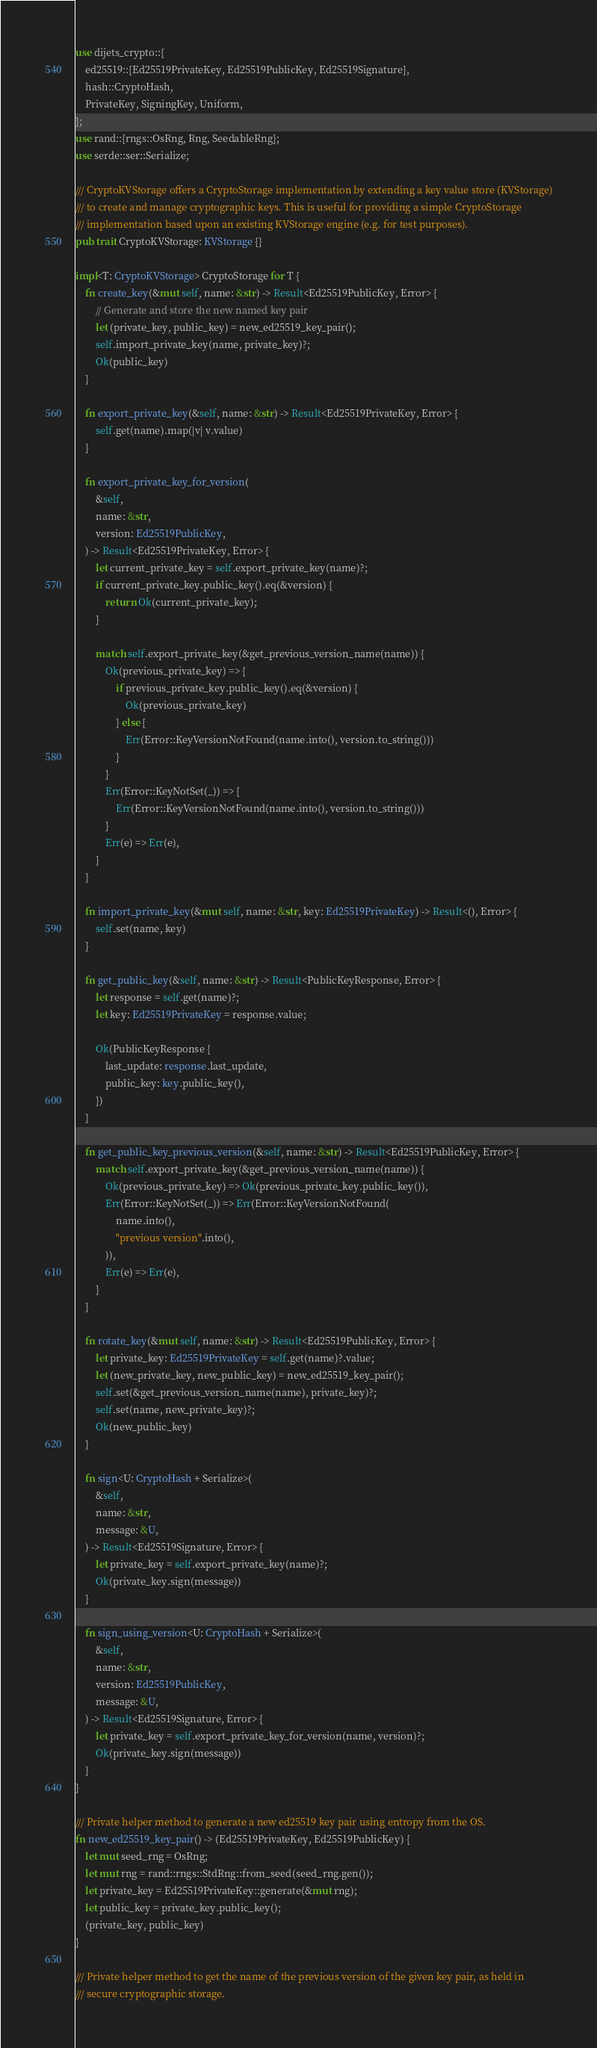Convert code to text. <code><loc_0><loc_0><loc_500><loc_500><_Rust_>use dijets_crypto::{
    ed25519::{Ed25519PrivateKey, Ed25519PublicKey, Ed25519Signature},
    hash::CryptoHash,
    PrivateKey, SigningKey, Uniform,
};
use rand::{rngs::OsRng, Rng, SeedableRng};
use serde::ser::Serialize;

/// CryptoKVStorage offers a CryptoStorage implementation by extending a key value store (KVStorage)
/// to create and manage cryptographic keys. This is useful for providing a simple CryptoStorage
/// implementation based upon an existing KVStorage engine (e.g. for test purposes).
pub trait CryptoKVStorage: KVStorage {}

impl<T: CryptoKVStorage> CryptoStorage for T {
    fn create_key(&mut self, name: &str) -> Result<Ed25519PublicKey, Error> {
        // Generate and store the new named key pair
        let (private_key, public_key) = new_ed25519_key_pair();
        self.import_private_key(name, private_key)?;
        Ok(public_key)
    }

    fn export_private_key(&self, name: &str) -> Result<Ed25519PrivateKey, Error> {
        self.get(name).map(|v| v.value)
    }

    fn export_private_key_for_version(
        &self,
        name: &str,
        version: Ed25519PublicKey,
    ) -> Result<Ed25519PrivateKey, Error> {
        let current_private_key = self.export_private_key(name)?;
        if current_private_key.public_key().eq(&version) {
            return Ok(current_private_key);
        }

        match self.export_private_key(&get_previous_version_name(name)) {
            Ok(previous_private_key) => {
                if previous_private_key.public_key().eq(&version) {
                    Ok(previous_private_key)
                } else {
                    Err(Error::KeyVersionNotFound(name.into(), version.to_string()))
                }
            }
            Err(Error::KeyNotSet(_)) => {
                Err(Error::KeyVersionNotFound(name.into(), version.to_string()))
            }
            Err(e) => Err(e),
        }
    }

    fn import_private_key(&mut self, name: &str, key: Ed25519PrivateKey) -> Result<(), Error> {
        self.set(name, key)
    }

    fn get_public_key(&self, name: &str) -> Result<PublicKeyResponse, Error> {
        let response = self.get(name)?;
        let key: Ed25519PrivateKey = response.value;

        Ok(PublicKeyResponse {
            last_update: response.last_update,
            public_key: key.public_key(),
        })
    }

    fn get_public_key_previous_version(&self, name: &str) -> Result<Ed25519PublicKey, Error> {
        match self.export_private_key(&get_previous_version_name(name)) {
            Ok(previous_private_key) => Ok(previous_private_key.public_key()),
            Err(Error::KeyNotSet(_)) => Err(Error::KeyVersionNotFound(
                name.into(),
                "previous version".into(),
            )),
            Err(e) => Err(e),
        }
    }

    fn rotate_key(&mut self, name: &str) -> Result<Ed25519PublicKey, Error> {
        let private_key: Ed25519PrivateKey = self.get(name)?.value;
        let (new_private_key, new_public_key) = new_ed25519_key_pair();
        self.set(&get_previous_version_name(name), private_key)?;
        self.set(name, new_private_key)?;
        Ok(new_public_key)
    }

    fn sign<U: CryptoHash + Serialize>(
        &self,
        name: &str,
        message: &U,
    ) -> Result<Ed25519Signature, Error> {
        let private_key = self.export_private_key(name)?;
        Ok(private_key.sign(message))
    }

    fn sign_using_version<U: CryptoHash + Serialize>(
        &self,
        name: &str,
        version: Ed25519PublicKey,
        message: &U,
    ) -> Result<Ed25519Signature, Error> {
        let private_key = self.export_private_key_for_version(name, version)?;
        Ok(private_key.sign(message))
    }
}

/// Private helper method to generate a new ed25519 key pair using entropy from the OS.
fn new_ed25519_key_pair() -> (Ed25519PrivateKey, Ed25519PublicKey) {
    let mut seed_rng = OsRng;
    let mut rng = rand::rngs::StdRng::from_seed(seed_rng.gen());
    let private_key = Ed25519PrivateKey::generate(&mut rng);
    let public_key = private_key.public_key();
    (private_key, public_key)
}

/// Private helper method to get the name of the previous version of the given key pair, as held in
/// secure cryptographic storage.</code> 